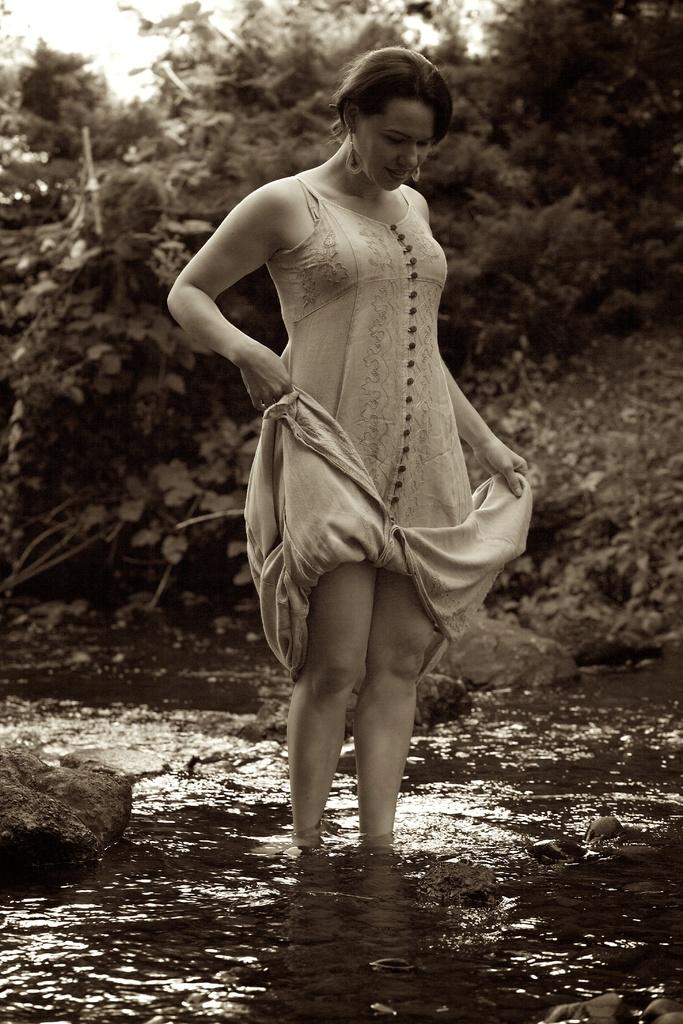What is the color scheme of the image? The image is black and white. What can be seen in the foreground of the image? There is a lady standing in the image. What type of natural environment is visible in the background of the image? There are trees in the background of the image. What is visible at the bottom of the image? There is water visible at the bottom of the image. What type of geological feature can be seen in the image? There are rocks visible in the image. How many spiders are crawling on the lady's shoulder in the image? There are no spiders visible on the lady's shoulder in the image. What type of ship can be seen sailing in the water at the bottom of the image? There is no ship present in the image; it only features water at the bottom. 